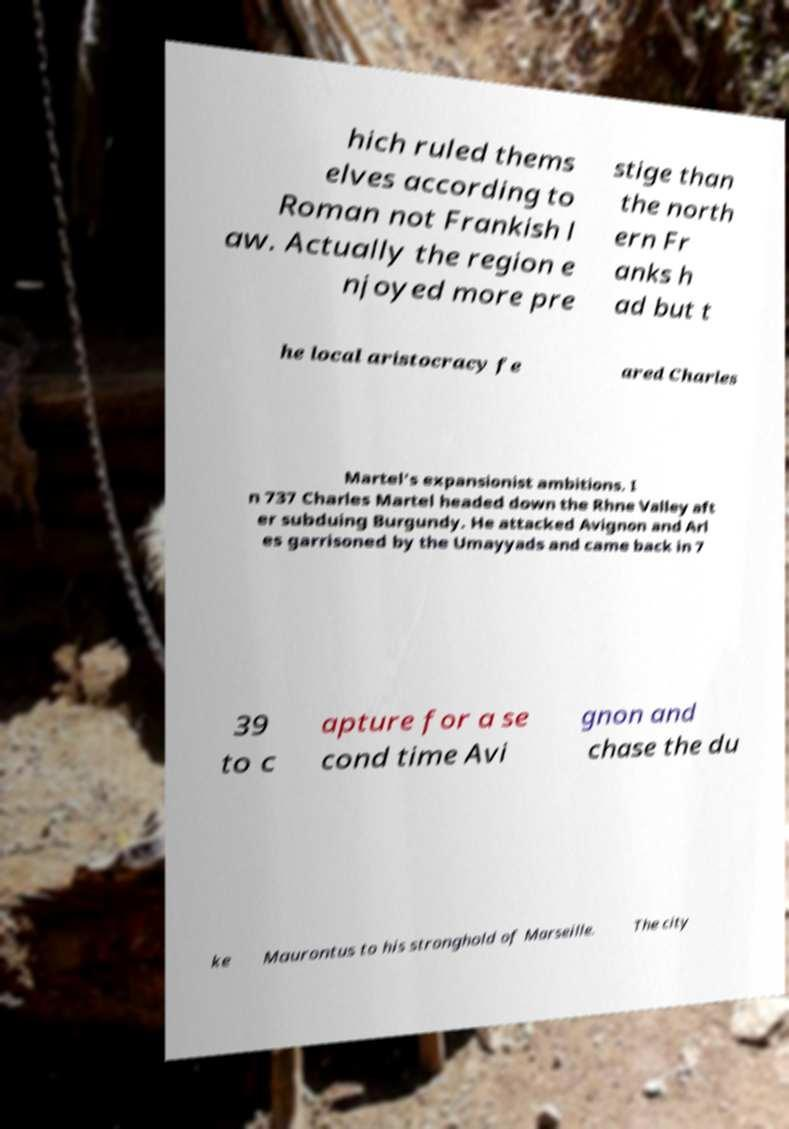For documentation purposes, I need the text within this image transcribed. Could you provide that? hich ruled thems elves according to Roman not Frankish l aw. Actually the region e njoyed more pre stige than the north ern Fr anks h ad but t he local aristocracy fe ared Charles Martel's expansionist ambitions. I n 737 Charles Martel headed down the Rhne Valley aft er subduing Burgundy. He attacked Avignon and Arl es garrisoned by the Umayyads and came back in 7 39 to c apture for a se cond time Avi gnon and chase the du ke Maurontus to his stronghold of Marseille. The city 